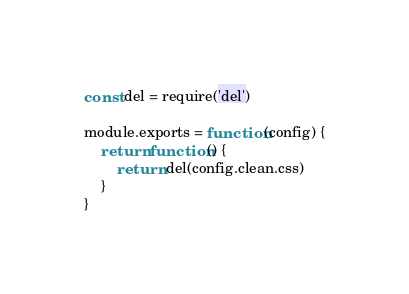Convert code to text. <code><loc_0><loc_0><loc_500><loc_500><_JavaScript_>const del = require('del')

module.exports = function(config) {
    return function() {
        return del(config.clean.css)
    }
}
</code> 